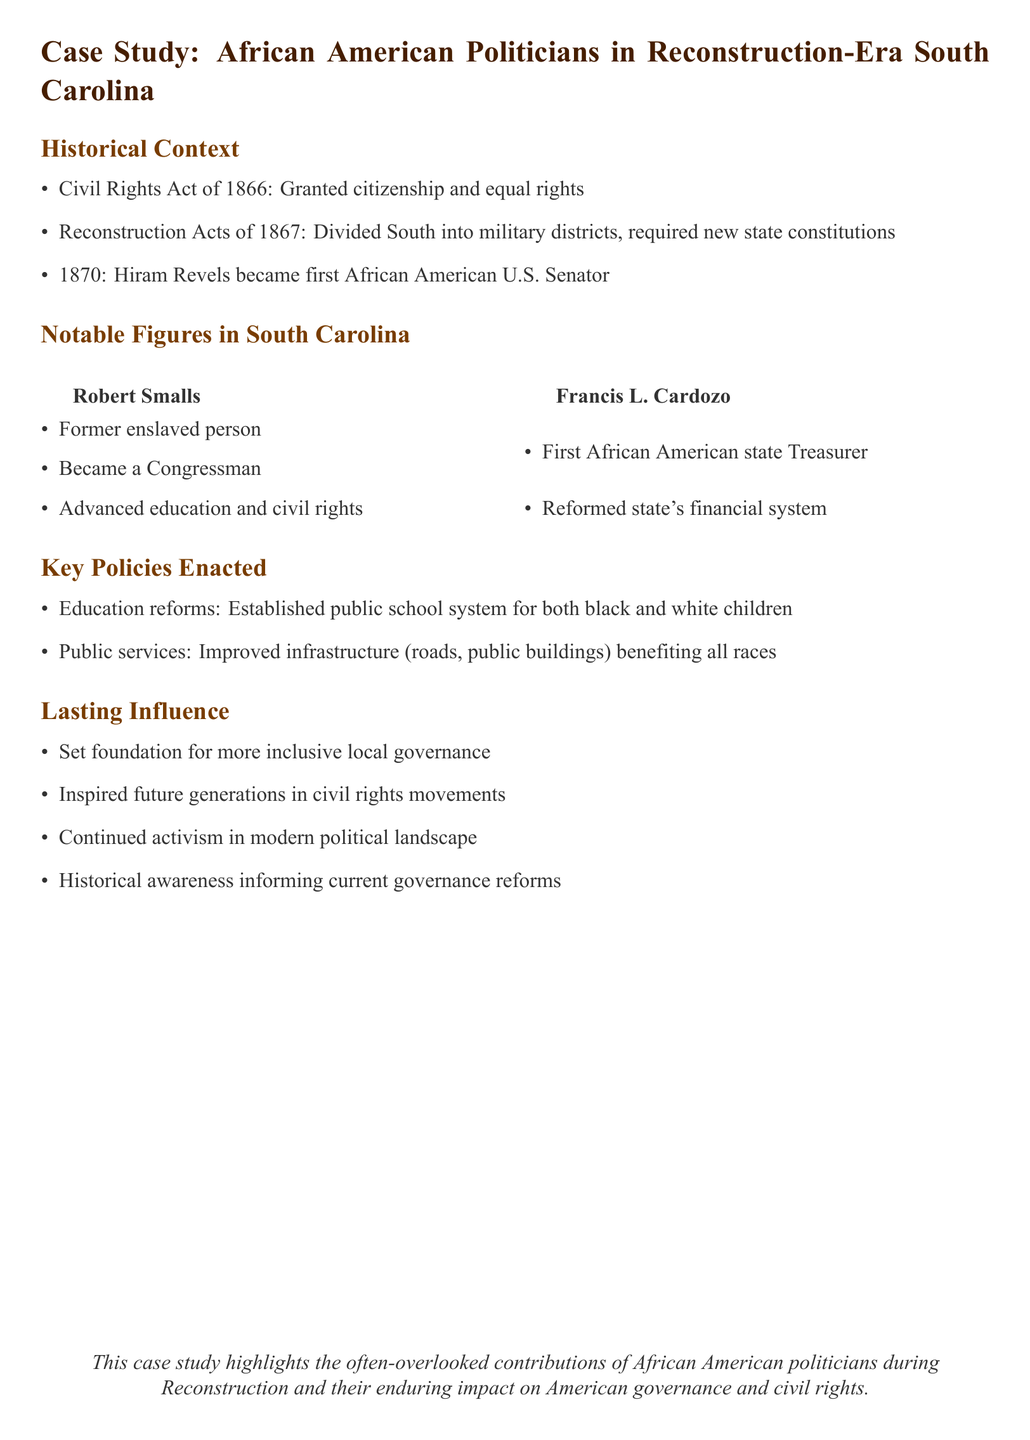What year did Hiram Revels become a U.S. Senator? Hiram Revels became a U.S. Senator in 1870, as stated in the historical context section.
Answer: 1870 Who was the first African American state Treasurer in South Carolina? The document mentions Francis L. Cardozo as the first African American state Treasurer.
Answer: Francis L. Cardozo What major act granted citizenship and equal rights to African Americans? The document references the Civil Rights Act of 1866 as granting citizenship and equal rights.
Answer: Civil Rights Act of 1866 Which politician advanced education and civil rights during Reconstruction? Robert Smalls is noted in the document for his contributions to education and civil rights.
Answer: Robert Smalls What type of reforms were established for education during Reconstruction? The document states that education reforms included establishing a public school system for both black and white children.
Answer: Public school system How did African American politicians during Reconstruction influence local governance structures? Their influence included setting foundations for more inclusive governance, as mentioned in the lasting influence section.
Answer: More inclusive local governance What infrastructure improvements were made during Reconstruction? The document notes improvements in roads and public buildings that benefited all races.
Answer: Improved infrastructure Which notable figure in South Carolina is recognized for reforming the financial system? Francis L. Cardozo is recognized for reforming South Carolina's financial system.
Answer: Francis L. Cardozo 